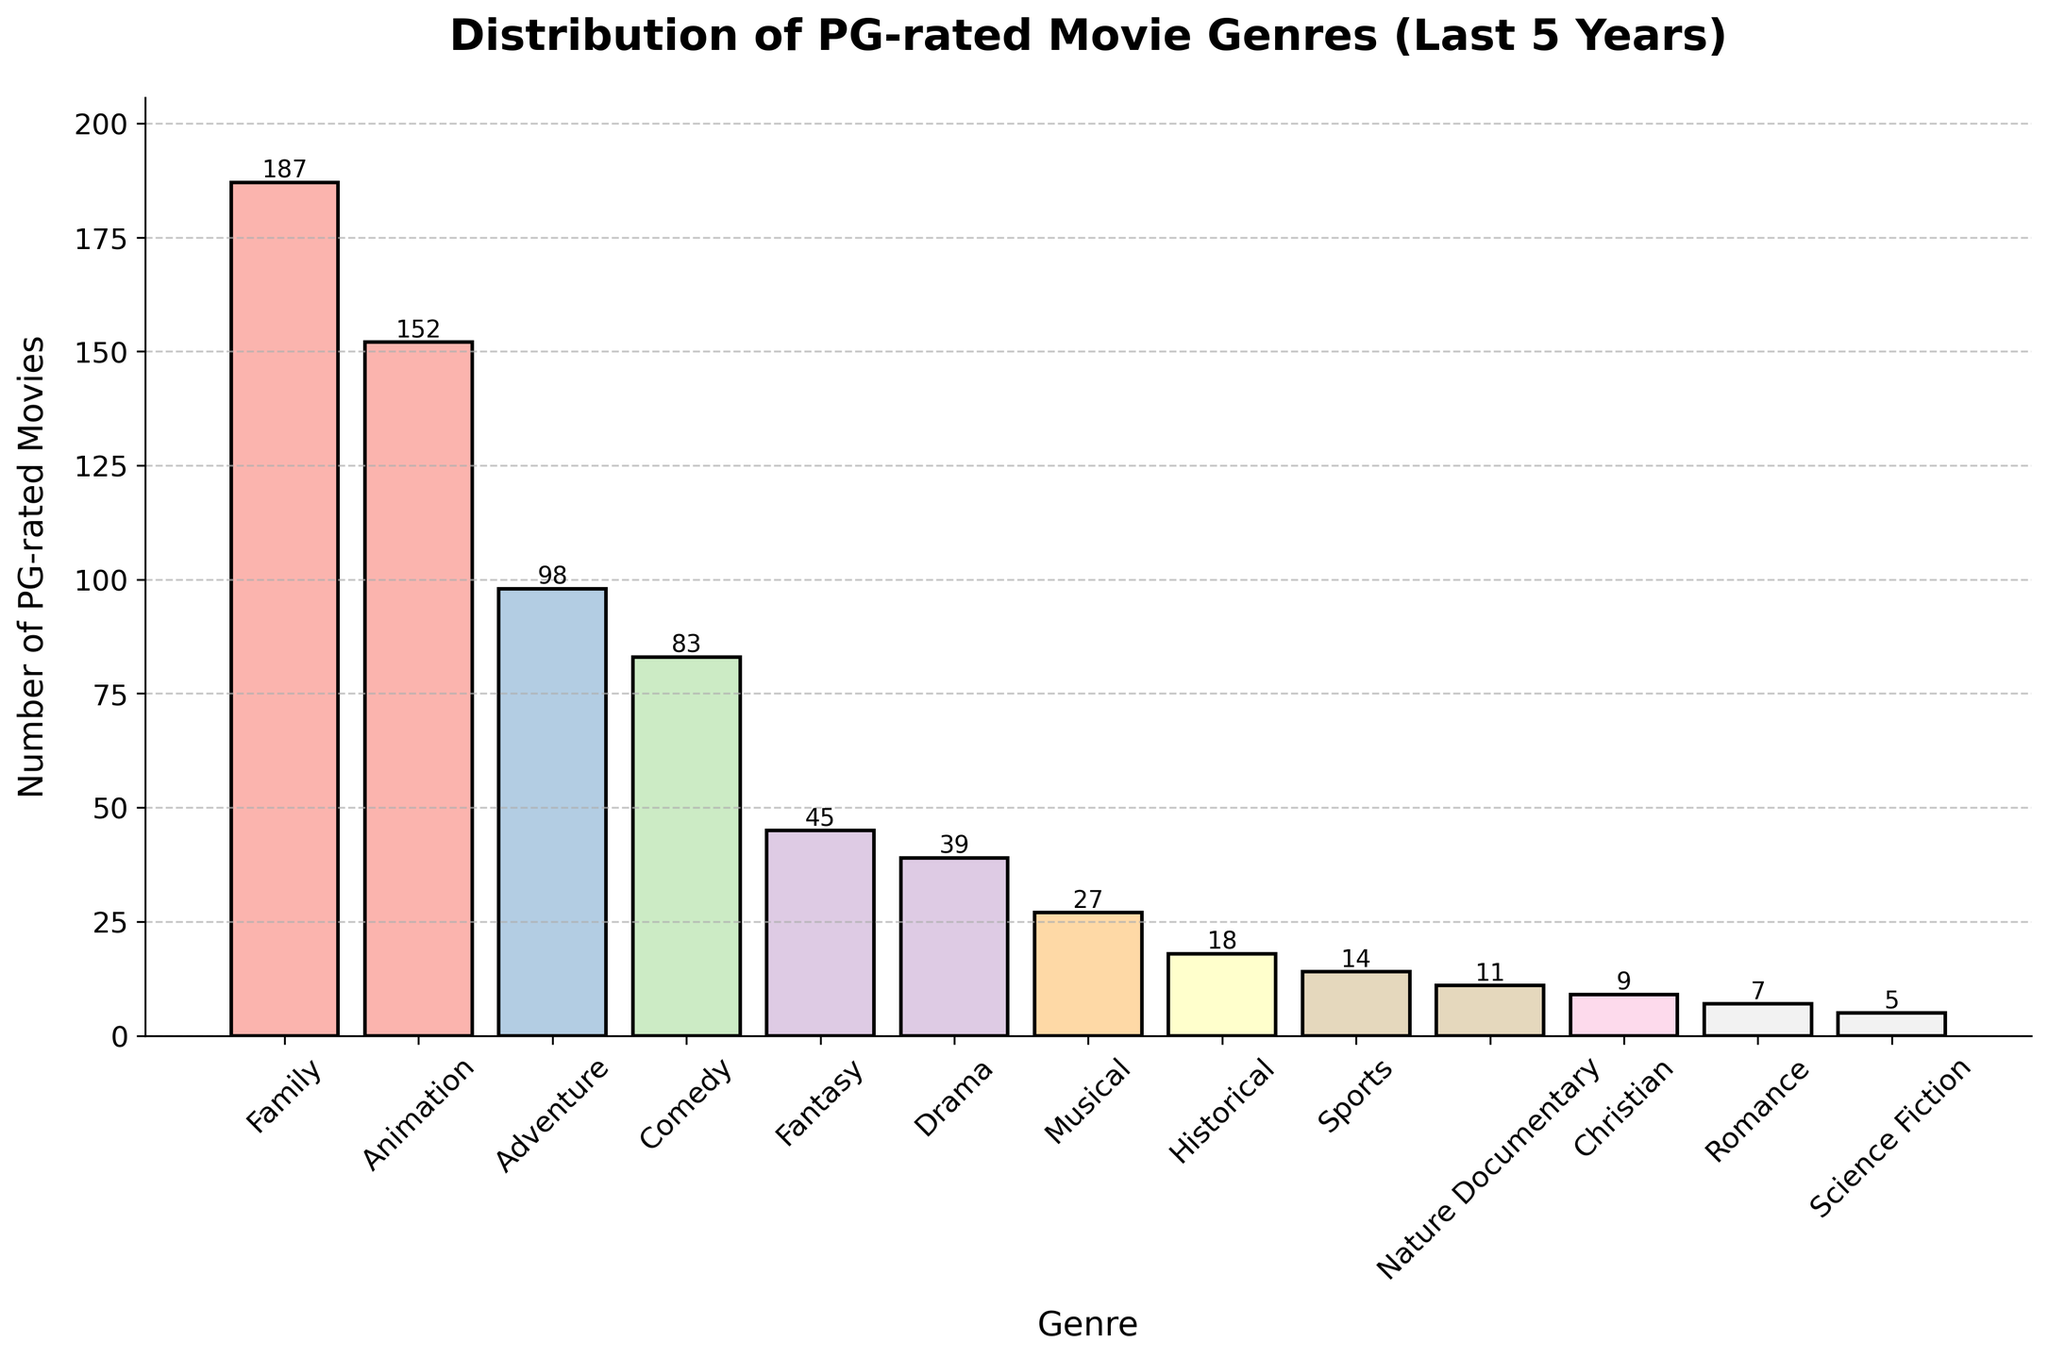what is the total number of PG-rated movies released in the last 5 years? Sum up all the values in the Number of PG-rated Movies column: (187 + 152 + 98 + 83 + 45 + 39 + 27 + 18 + 14 + 11 + 9 + 7 + 5) = 695
Answer: 695 Which genre has the most PG-rated movies? Look for the highest bar in the bar chart, which corresponds to the Family genre with 187 movies.
Answer: Family How many more PG-rated musicals are there than PG-rated Christian movies? Compare the heights of the Musical (27 movies) and Christian (9 movies) bars. The difference is 27 - 9 = 18 movies.
Answer: 18 What percentage of PG-rated movies are adventure and comedy combined? First, sum the number of Adventure (98) and Comedy (83) movies: 98 + 83 = 181. Then, divide by the total number of PG-rated movies (695) and multiply by 100 to get the percentage: (181 / 695) * 100 ≈ 26.04%.
Answer: 26.04% Is the number of PG-rated animation movies greater than the total number of PG-rated sports, historical, and nature documentary movies? Sum the number of Sports (14), Historical (18), and Nature Documentary (11) movies: 14 + 18 + 11 = 43. Compare this with the number of Animation movies (152), which is greater than 43.
Answer: Yes Which genre, having less than 50 PG-rated movies, has the highest count? Among genres with less than 50 movies, compare Fantasy (45), Drama (39), Musical (27), Historical (18), Sports (14), Nature Documentary (11), Christian (9), Romance (7), and Science Fiction (5). Fantasy has the highest count with 45 movies.
Answer: Fantasy What is the difference in the number of PG-rated movies between the genre with the second highest count and the genre with the second lowest count? The genre with the second highest count is Animation (152) and the genre with the second lowest count is Romance (7). The difference is 152 - 7 = 145.
Answer: 145 